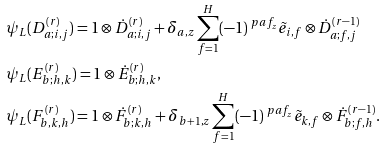<formula> <loc_0><loc_0><loc_500><loc_500>& \psi _ { L } ( D _ { a ; i , j } ^ { ( r ) } ) = 1 \otimes \dot { D } _ { a ; i , j } ^ { ( r ) } + \delta _ { a , z } \sum _ { f = 1 } ^ { H } ( - 1 ) ^ { \ p a { f } _ { z } } \tilde { e } _ { i , f } \otimes \dot { D } _ { a ; f , j } ^ { ( r - 1 ) } \\ & \psi _ { L } ( E _ { b ; h , k } ^ { ( r ) } ) = 1 \otimes \dot { E } _ { b ; h , k } ^ { ( r ) } , \\ & \psi _ { L } ( F _ { b , k , h } ^ { ( r ) } ) = 1 \otimes \dot { F } _ { b ; k , h } ^ { ( r ) } + \delta _ { b + 1 , z } \sum _ { f = 1 } ^ { H } ( - 1 ) ^ { \ p a { f } _ { z } } \tilde { e } _ { k , f } \otimes \dot { F } _ { b ; f , h } ^ { ( r - 1 ) } .</formula> 